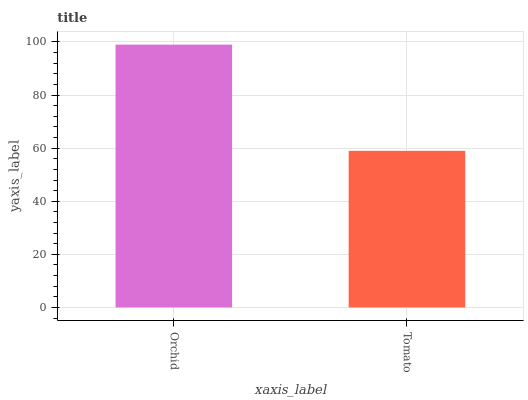Is Tomato the minimum?
Answer yes or no. Yes. Is Orchid the maximum?
Answer yes or no. Yes. Is Tomato the maximum?
Answer yes or no. No. Is Orchid greater than Tomato?
Answer yes or no. Yes. Is Tomato less than Orchid?
Answer yes or no. Yes. Is Tomato greater than Orchid?
Answer yes or no. No. Is Orchid less than Tomato?
Answer yes or no. No. Is Orchid the high median?
Answer yes or no. Yes. Is Tomato the low median?
Answer yes or no. Yes. Is Tomato the high median?
Answer yes or no. No. Is Orchid the low median?
Answer yes or no. No. 